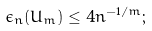<formula> <loc_0><loc_0><loc_500><loc_500>\epsilon _ { n } ( U _ { m } ) \leq 4 n ^ { - 1 / m } ;</formula> 